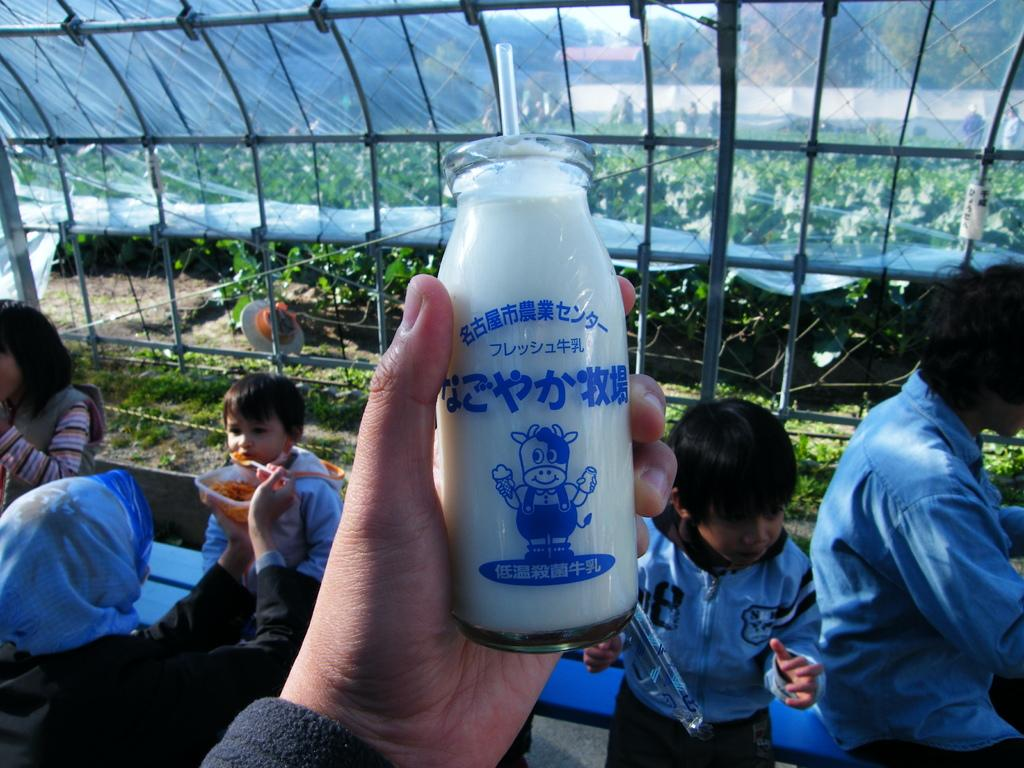What is the man in the image holding? The man is holding a bottle in the image. What are the kids doing in the image? The kids are sitting on a bench in the image. What type of vegetation can be seen in the image? There are plants in the image. What kind of barrier is present in the image? There is fencing in the image. What type of acoustics can be heard from the bear in the image? There is no bear present in the image, so there are no acoustics to be heard. What is the man holding in his quiver in the image? There is no quiver present in the image, and the man is holding a bottle, not arrows. 